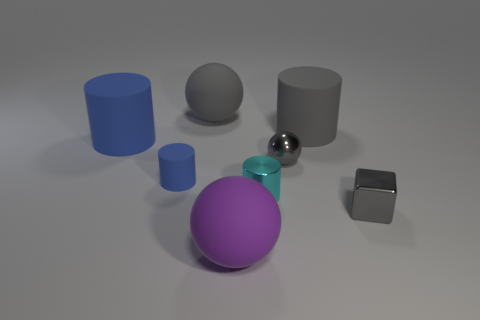Is the color of the large sphere behind the large purple matte thing the same as the matte cylinder right of the purple rubber object?
Make the answer very short. Yes. The large gray object that is to the left of the sphere in front of the gray cube is what shape?
Your answer should be very brief. Sphere. How many other objects are the same color as the small shiny cube?
Offer a terse response. 3. Are the gray object to the left of the small cyan shiny object and the gray ball that is right of the tiny metallic cylinder made of the same material?
Offer a terse response. No. There is a cyan metallic thing that is on the right side of the purple rubber object; what size is it?
Your answer should be very brief. Small. What material is the small gray object that is the same shape as the large purple thing?
Offer a very short reply. Metal. What shape is the big thing that is in front of the gray cube?
Provide a succinct answer. Sphere. What number of other things have the same shape as the small blue matte object?
Make the answer very short. 3. Is the number of tiny spheres that are in front of the gray shiny sphere the same as the number of rubber things that are on the left side of the small gray cube?
Ensure brevity in your answer.  No. Are there any small gray things made of the same material as the cyan cylinder?
Your answer should be very brief. Yes. 